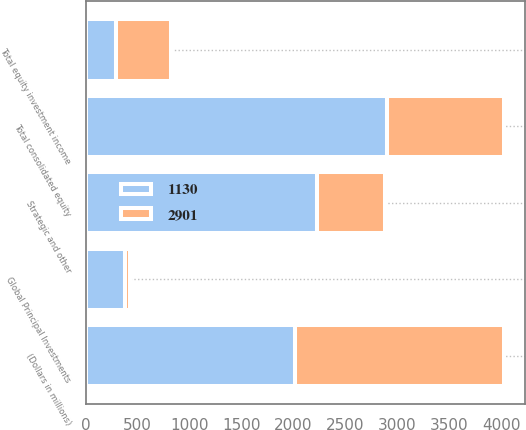<chart> <loc_0><loc_0><loc_500><loc_500><stacked_bar_chart><ecel><fcel>(Dollars in millions)<fcel>Global Principal Investments<fcel>Strategic and other<fcel>Total equity investment income<fcel>Total consolidated equity<nl><fcel>2901<fcel>2014<fcel>46<fcel>647<fcel>529<fcel>1130<nl><fcel>1130<fcel>2013<fcel>379<fcel>2231<fcel>291<fcel>2901<nl></chart> 